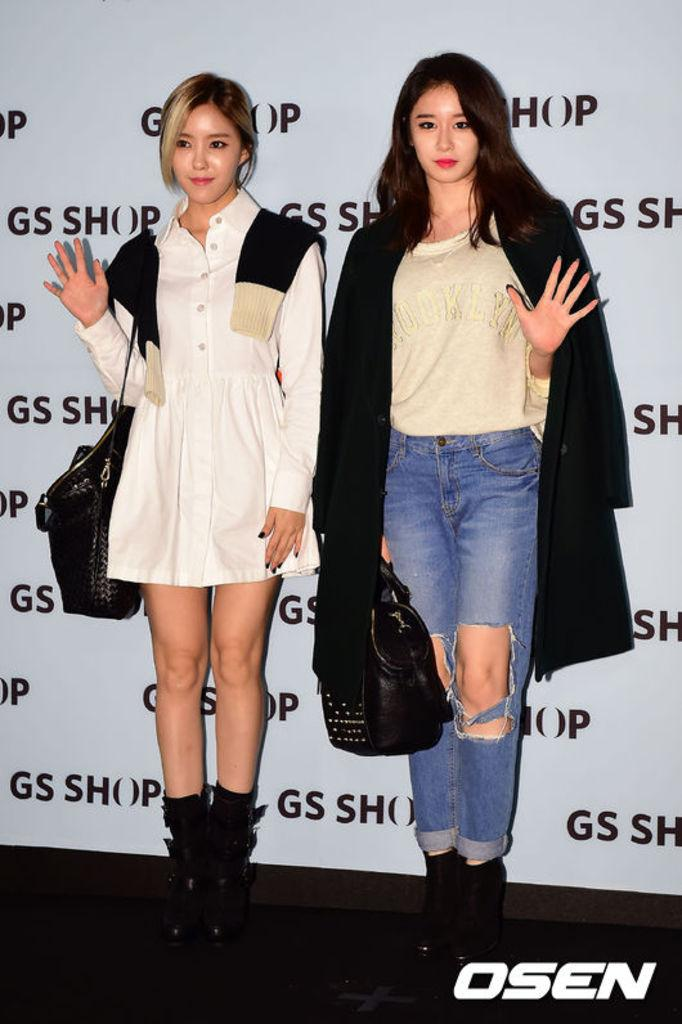How many people are in the image? There are two women in the image. What are the women doing in the image? The women are standing and holding a bag. What can be seen in the background of the image? There is a board visible in the background of the image. What type of clocks can be seen hanging on the wall in the image? There are no clocks visible in the image. What nation are the women representing in the image? The image does not provide any information about the women's nationality or the nation they might be representing. 